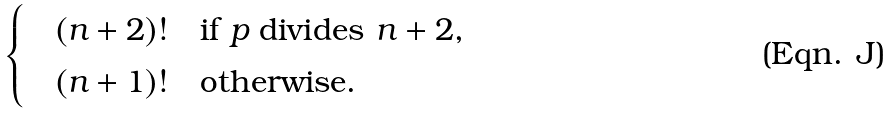Convert formula to latex. <formula><loc_0><loc_0><loc_500><loc_500>\begin{cases} \quad ( n + 2 ) ! & \text {if $p$ divides $n+2$,} \\ \quad ( n + 1 ) ! & \text {otherwise.} \end{cases}</formula> 